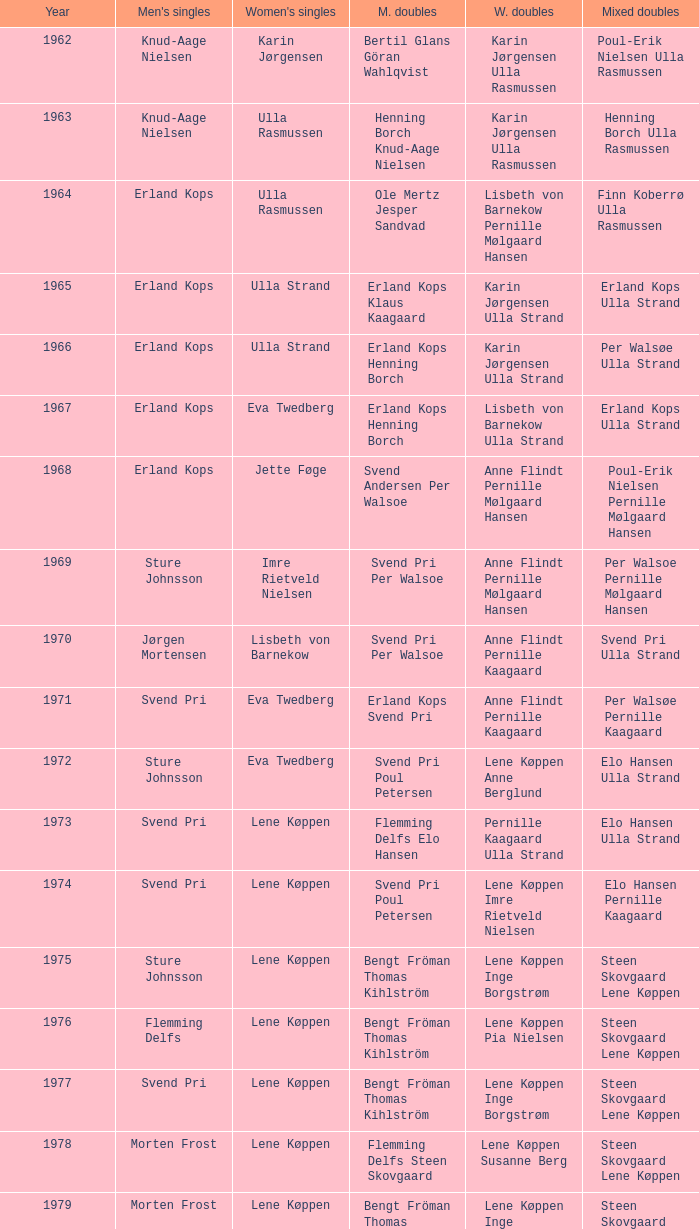Who won the men's doubles the year Pernille Nedergaard won the women's singles? Thomas Stuer-Lauridsen Max Gandrup. 